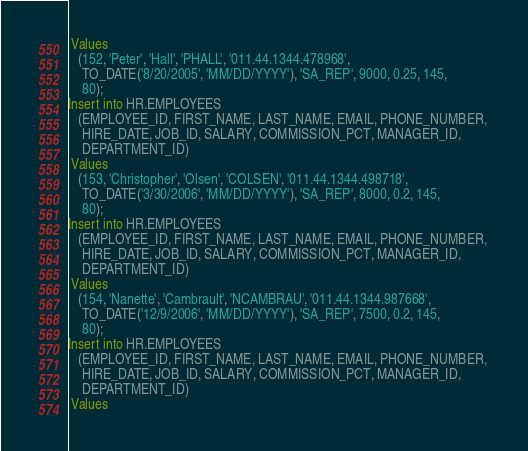<code> <loc_0><loc_0><loc_500><loc_500><_SQL_> Values
   (152, 'Peter', 'Hall', 'PHALL', '011.44.1344.478968', 
    TO_DATE('8/20/2005', 'MM/DD/YYYY'), 'SA_REP', 9000, 0.25, 145, 
    80);
Insert into HR.EMPLOYEES
   (EMPLOYEE_ID, FIRST_NAME, LAST_NAME, EMAIL, PHONE_NUMBER, 
    HIRE_DATE, JOB_ID, SALARY, COMMISSION_PCT, MANAGER_ID, 
    DEPARTMENT_ID)
 Values
   (153, 'Christopher', 'Olsen', 'COLSEN', '011.44.1344.498718', 
    TO_DATE('3/30/2006', 'MM/DD/YYYY'), 'SA_REP', 8000, 0.2, 145, 
    80);
Insert into HR.EMPLOYEES
   (EMPLOYEE_ID, FIRST_NAME, LAST_NAME, EMAIL, PHONE_NUMBER, 
    HIRE_DATE, JOB_ID, SALARY, COMMISSION_PCT, MANAGER_ID, 
    DEPARTMENT_ID)
 Values
   (154, 'Nanette', 'Cambrault', 'NCAMBRAU', '011.44.1344.987668', 
    TO_DATE('12/9/2006', 'MM/DD/YYYY'), 'SA_REP', 7500, 0.2, 145, 
    80);
Insert into HR.EMPLOYEES
   (EMPLOYEE_ID, FIRST_NAME, LAST_NAME, EMAIL, PHONE_NUMBER, 
    HIRE_DATE, JOB_ID, SALARY, COMMISSION_PCT, MANAGER_ID, 
    DEPARTMENT_ID)
 Values</code> 